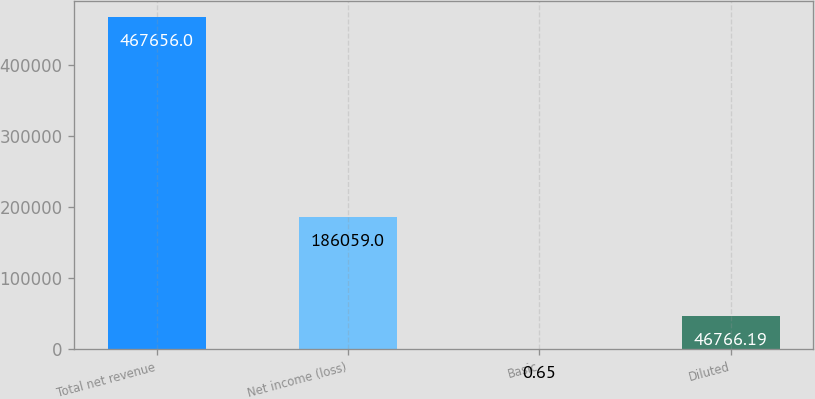Convert chart to OTSL. <chart><loc_0><loc_0><loc_500><loc_500><bar_chart><fcel>Total net revenue<fcel>Net income (loss)<fcel>Basic<fcel>Diluted<nl><fcel>467656<fcel>186059<fcel>0.65<fcel>46766.2<nl></chart> 